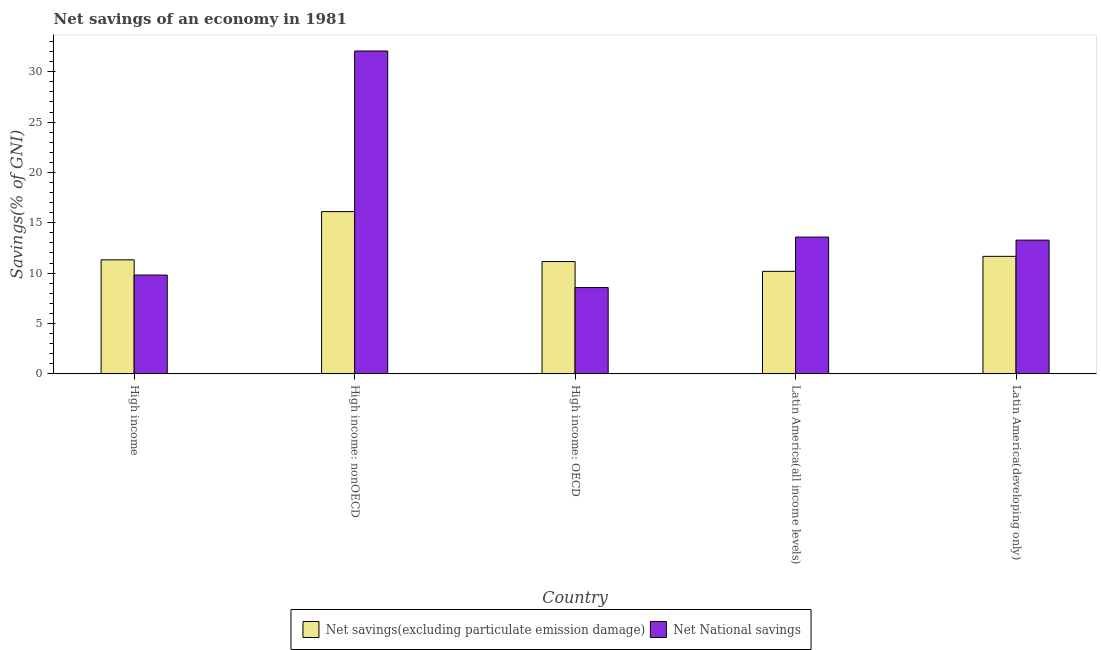How many different coloured bars are there?
Your response must be concise. 2. How many groups of bars are there?
Keep it short and to the point. 5. Are the number of bars on each tick of the X-axis equal?
Offer a very short reply. Yes. How many bars are there on the 3rd tick from the left?
Offer a very short reply. 2. What is the label of the 5th group of bars from the left?
Your answer should be very brief. Latin America(developing only). In how many cases, is the number of bars for a given country not equal to the number of legend labels?
Give a very brief answer. 0. What is the net national savings in Latin America(all income levels)?
Keep it short and to the point. 13.58. Across all countries, what is the maximum net savings(excluding particulate emission damage)?
Ensure brevity in your answer.  16.11. Across all countries, what is the minimum net savings(excluding particulate emission damage)?
Your response must be concise. 10.18. In which country was the net national savings maximum?
Offer a terse response. High income: nonOECD. In which country was the net savings(excluding particulate emission damage) minimum?
Your response must be concise. Latin America(all income levels). What is the total net savings(excluding particulate emission damage) in the graph?
Your answer should be very brief. 60.41. What is the difference between the net national savings in High income and that in Latin America(developing only)?
Your answer should be very brief. -3.47. What is the difference between the net national savings in Latin America(all income levels) and the net savings(excluding particulate emission damage) in Latin America(developing only)?
Provide a short and direct response. 1.91. What is the average net national savings per country?
Offer a very short reply. 15.46. What is the difference between the net savings(excluding particulate emission damage) and net national savings in Latin America(developing only)?
Make the answer very short. -1.61. In how many countries, is the net savings(excluding particulate emission damage) greater than 26 %?
Your response must be concise. 0. What is the ratio of the net national savings in High income to that in High income: nonOECD?
Your answer should be very brief. 0.31. What is the difference between the highest and the second highest net savings(excluding particulate emission damage)?
Your response must be concise. 4.45. What is the difference between the highest and the lowest net savings(excluding particulate emission damage)?
Offer a terse response. 5.94. Is the sum of the net national savings in High income: OECD and High income: nonOECD greater than the maximum net savings(excluding particulate emission damage) across all countries?
Provide a succinct answer. Yes. What does the 1st bar from the left in Latin America(all income levels) represents?
Keep it short and to the point. Net savings(excluding particulate emission damage). What does the 2nd bar from the right in High income represents?
Your response must be concise. Net savings(excluding particulate emission damage). How many countries are there in the graph?
Provide a succinct answer. 5. What is the difference between two consecutive major ticks on the Y-axis?
Make the answer very short. 5. Does the graph contain any zero values?
Offer a very short reply. No. How many legend labels are there?
Ensure brevity in your answer.  2. How are the legend labels stacked?
Offer a very short reply. Horizontal. What is the title of the graph?
Keep it short and to the point. Net savings of an economy in 1981. What is the label or title of the Y-axis?
Keep it short and to the point. Savings(% of GNI). What is the Savings(% of GNI) of Net savings(excluding particulate emission damage) in High income?
Your response must be concise. 11.32. What is the Savings(% of GNI) in Net National savings in High income?
Ensure brevity in your answer.  9.81. What is the Savings(% of GNI) in Net savings(excluding particulate emission damage) in High income: nonOECD?
Your answer should be very brief. 16.11. What is the Savings(% of GNI) in Net National savings in High income: nonOECD?
Provide a succinct answer. 32.07. What is the Savings(% of GNI) in Net savings(excluding particulate emission damage) in High income: OECD?
Provide a succinct answer. 11.14. What is the Savings(% of GNI) of Net National savings in High income: OECD?
Provide a short and direct response. 8.56. What is the Savings(% of GNI) in Net savings(excluding particulate emission damage) in Latin America(all income levels)?
Offer a terse response. 10.18. What is the Savings(% of GNI) in Net National savings in Latin America(all income levels)?
Make the answer very short. 13.58. What is the Savings(% of GNI) in Net savings(excluding particulate emission damage) in Latin America(developing only)?
Provide a succinct answer. 11.66. What is the Savings(% of GNI) in Net National savings in Latin America(developing only)?
Ensure brevity in your answer.  13.27. Across all countries, what is the maximum Savings(% of GNI) in Net savings(excluding particulate emission damage)?
Your answer should be compact. 16.11. Across all countries, what is the maximum Savings(% of GNI) in Net National savings?
Provide a short and direct response. 32.07. Across all countries, what is the minimum Savings(% of GNI) in Net savings(excluding particulate emission damage)?
Your response must be concise. 10.18. Across all countries, what is the minimum Savings(% of GNI) in Net National savings?
Offer a very short reply. 8.56. What is the total Savings(% of GNI) of Net savings(excluding particulate emission damage) in the graph?
Your response must be concise. 60.41. What is the total Savings(% of GNI) in Net National savings in the graph?
Ensure brevity in your answer.  77.29. What is the difference between the Savings(% of GNI) of Net savings(excluding particulate emission damage) in High income and that in High income: nonOECD?
Your answer should be compact. -4.79. What is the difference between the Savings(% of GNI) in Net National savings in High income and that in High income: nonOECD?
Your answer should be very brief. -22.26. What is the difference between the Savings(% of GNI) of Net savings(excluding particulate emission damage) in High income and that in High income: OECD?
Your response must be concise. 0.17. What is the difference between the Savings(% of GNI) in Net National savings in High income and that in High income: OECD?
Offer a very short reply. 1.24. What is the difference between the Savings(% of GNI) of Net savings(excluding particulate emission damage) in High income and that in Latin America(all income levels)?
Make the answer very short. 1.14. What is the difference between the Savings(% of GNI) of Net National savings in High income and that in Latin America(all income levels)?
Ensure brevity in your answer.  -3.77. What is the difference between the Savings(% of GNI) of Net savings(excluding particulate emission damage) in High income and that in Latin America(developing only)?
Provide a succinct answer. -0.35. What is the difference between the Savings(% of GNI) of Net National savings in High income and that in Latin America(developing only)?
Keep it short and to the point. -3.47. What is the difference between the Savings(% of GNI) of Net savings(excluding particulate emission damage) in High income: nonOECD and that in High income: OECD?
Ensure brevity in your answer.  4.97. What is the difference between the Savings(% of GNI) of Net National savings in High income: nonOECD and that in High income: OECD?
Your answer should be very brief. 23.5. What is the difference between the Savings(% of GNI) of Net savings(excluding particulate emission damage) in High income: nonOECD and that in Latin America(all income levels)?
Offer a terse response. 5.94. What is the difference between the Savings(% of GNI) of Net National savings in High income: nonOECD and that in Latin America(all income levels)?
Provide a short and direct response. 18.49. What is the difference between the Savings(% of GNI) of Net savings(excluding particulate emission damage) in High income: nonOECD and that in Latin America(developing only)?
Provide a succinct answer. 4.45. What is the difference between the Savings(% of GNI) of Net National savings in High income: nonOECD and that in Latin America(developing only)?
Keep it short and to the point. 18.79. What is the difference between the Savings(% of GNI) of Net savings(excluding particulate emission damage) in High income: OECD and that in Latin America(all income levels)?
Offer a terse response. 0.97. What is the difference between the Savings(% of GNI) of Net National savings in High income: OECD and that in Latin America(all income levels)?
Your answer should be compact. -5.02. What is the difference between the Savings(% of GNI) of Net savings(excluding particulate emission damage) in High income: OECD and that in Latin America(developing only)?
Make the answer very short. -0.52. What is the difference between the Savings(% of GNI) in Net National savings in High income: OECD and that in Latin America(developing only)?
Provide a succinct answer. -4.71. What is the difference between the Savings(% of GNI) of Net savings(excluding particulate emission damage) in Latin America(all income levels) and that in Latin America(developing only)?
Ensure brevity in your answer.  -1.49. What is the difference between the Savings(% of GNI) of Net National savings in Latin America(all income levels) and that in Latin America(developing only)?
Offer a very short reply. 0.3. What is the difference between the Savings(% of GNI) of Net savings(excluding particulate emission damage) in High income and the Savings(% of GNI) of Net National savings in High income: nonOECD?
Keep it short and to the point. -20.75. What is the difference between the Savings(% of GNI) in Net savings(excluding particulate emission damage) in High income and the Savings(% of GNI) in Net National savings in High income: OECD?
Your response must be concise. 2.76. What is the difference between the Savings(% of GNI) in Net savings(excluding particulate emission damage) in High income and the Savings(% of GNI) in Net National savings in Latin America(all income levels)?
Give a very brief answer. -2.26. What is the difference between the Savings(% of GNI) in Net savings(excluding particulate emission damage) in High income and the Savings(% of GNI) in Net National savings in Latin America(developing only)?
Your answer should be compact. -1.96. What is the difference between the Savings(% of GNI) of Net savings(excluding particulate emission damage) in High income: nonOECD and the Savings(% of GNI) of Net National savings in High income: OECD?
Keep it short and to the point. 7.55. What is the difference between the Savings(% of GNI) in Net savings(excluding particulate emission damage) in High income: nonOECD and the Savings(% of GNI) in Net National savings in Latin America(all income levels)?
Give a very brief answer. 2.53. What is the difference between the Savings(% of GNI) of Net savings(excluding particulate emission damage) in High income: nonOECD and the Savings(% of GNI) of Net National savings in Latin America(developing only)?
Your answer should be very brief. 2.84. What is the difference between the Savings(% of GNI) in Net savings(excluding particulate emission damage) in High income: OECD and the Savings(% of GNI) in Net National savings in Latin America(all income levels)?
Offer a very short reply. -2.43. What is the difference between the Savings(% of GNI) in Net savings(excluding particulate emission damage) in High income: OECD and the Savings(% of GNI) in Net National savings in Latin America(developing only)?
Make the answer very short. -2.13. What is the difference between the Savings(% of GNI) of Net savings(excluding particulate emission damage) in Latin America(all income levels) and the Savings(% of GNI) of Net National savings in Latin America(developing only)?
Your response must be concise. -3.1. What is the average Savings(% of GNI) of Net savings(excluding particulate emission damage) per country?
Ensure brevity in your answer.  12.08. What is the average Savings(% of GNI) of Net National savings per country?
Your answer should be very brief. 15.46. What is the difference between the Savings(% of GNI) in Net savings(excluding particulate emission damage) and Savings(% of GNI) in Net National savings in High income?
Your response must be concise. 1.51. What is the difference between the Savings(% of GNI) of Net savings(excluding particulate emission damage) and Savings(% of GNI) of Net National savings in High income: nonOECD?
Your answer should be compact. -15.96. What is the difference between the Savings(% of GNI) in Net savings(excluding particulate emission damage) and Savings(% of GNI) in Net National savings in High income: OECD?
Ensure brevity in your answer.  2.58. What is the difference between the Savings(% of GNI) in Net savings(excluding particulate emission damage) and Savings(% of GNI) in Net National savings in Latin America(all income levels)?
Keep it short and to the point. -3.4. What is the difference between the Savings(% of GNI) of Net savings(excluding particulate emission damage) and Savings(% of GNI) of Net National savings in Latin America(developing only)?
Offer a terse response. -1.61. What is the ratio of the Savings(% of GNI) in Net savings(excluding particulate emission damage) in High income to that in High income: nonOECD?
Offer a terse response. 0.7. What is the ratio of the Savings(% of GNI) of Net National savings in High income to that in High income: nonOECD?
Your answer should be very brief. 0.31. What is the ratio of the Savings(% of GNI) of Net savings(excluding particulate emission damage) in High income to that in High income: OECD?
Give a very brief answer. 1.02. What is the ratio of the Savings(% of GNI) in Net National savings in High income to that in High income: OECD?
Provide a succinct answer. 1.15. What is the ratio of the Savings(% of GNI) in Net savings(excluding particulate emission damage) in High income to that in Latin America(all income levels)?
Provide a short and direct response. 1.11. What is the ratio of the Savings(% of GNI) of Net National savings in High income to that in Latin America(all income levels)?
Provide a succinct answer. 0.72. What is the ratio of the Savings(% of GNI) in Net savings(excluding particulate emission damage) in High income to that in Latin America(developing only)?
Offer a terse response. 0.97. What is the ratio of the Savings(% of GNI) of Net National savings in High income to that in Latin America(developing only)?
Your response must be concise. 0.74. What is the ratio of the Savings(% of GNI) in Net savings(excluding particulate emission damage) in High income: nonOECD to that in High income: OECD?
Give a very brief answer. 1.45. What is the ratio of the Savings(% of GNI) in Net National savings in High income: nonOECD to that in High income: OECD?
Offer a very short reply. 3.75. What is the ratio of the Savings(% of GNI) of Net savings(excluding particulate emission damage) in High income: nonOECD to that in Latin America(all income levels)?
Make the answer very short. 1.58. What is the ratio of the Savings(% of GNI) in Net National savings in High income: nonOECD to that in Latin America(all income levels)?
Your response must be concise. 2.36. What is the ratio of the Savings(% of GNI) of Net savings(excluding particulate emission damage) in High income: nonOECD to that in Latin America(developing only)?
Ensure brevity in your answer.  1.38. What is the ratio of the Savings(% of GNI) of Net National savings in High income: nonOECD to that in Latin America(developing only)?
Ensure brevity in your answer.  2.42. What is the ratio of the Savings(% of GNI) in Net savings(excluding particulate emission damage) in High income: OECD to that in Latin America(all income levels)?
Ensure brevity in your answer.  1.1. What is the ratio of the Savings(% of GNI) of Net National savings in High income: OECD to that in Latin America(all income levels)?
Offer a terse response. 0.63. What is the ratio of the Savings(% of GNI) in Net savings(excluding particulate emission damage) in High income: OECD to that in Latin America(developing only)?
Provide a succinct answer. 0.96. What is the ratio of the Savings(% of GNI) of Net National savings in High income: OECD to that in Latin America(developing only)?
Your response must be concise. 0.65. What is the ratio of the Savings(% of GNI) of Net savings(excluding particulate emission damage) in Latin America(all income levels) to that in Latin America(developing only)?
Give a very brief answer. 0.87. What is the ratio of the Savings(% of GNI) of Net National savings in Latin America(all income levels) to that in Latin America(developing only)?
Your answer should be very brief. 1.02. What is the difference between the highest and the second highest Savings(% of GNI) in Net savings(excluding particulate emission damage)?
Your response must be concise. 4.45. What is the difference between the highest and the second highest Savings(% of GNI) in Net National savings?
Offer a very short reply. 18.49. What is the difference between the highest and the lowest Savings(% of GNI) of Net savings(excluding particulate emission damage)?
Your response must be concise. 5.94. What is the difference between the highest and the lowest Savings(% of GNI) in Net National savings?
Make the answer very short. 23.5. 